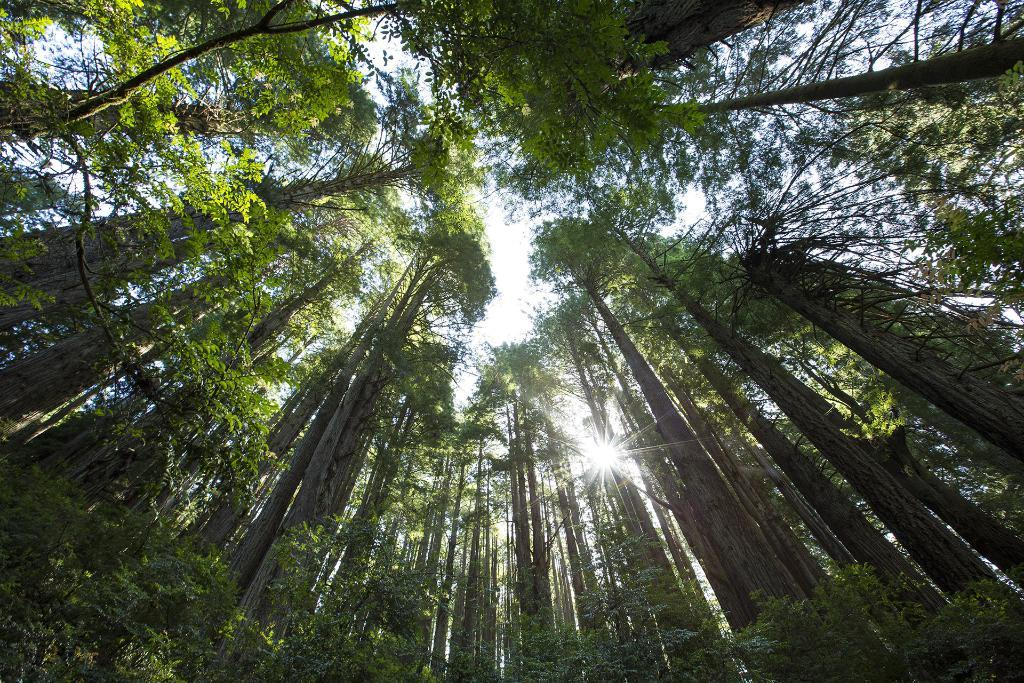What type of vegetation can be seen in the image? There are trees in the image. What part of the natural environment is visible in the background? The sky is visible in the background of the image. What celestial body is present in the center of the image? The sun is present in the center of the image. How many notes are attached to the trees in the image? There are no notes present in the image; it features trees and the sun. What type of animal can be seen interacting with the trees in the image? There are no animals, including rabbits, depicted interacting with the trees in the image. 